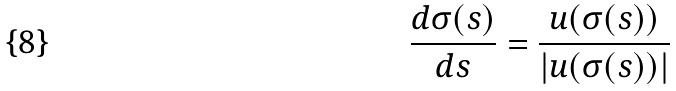Convert formula to latex. <formula><loc_0><loc_0><loc_500><loc_500>\frac { d \sigma ( s ) } { d s } = \frac { u ( \sigma ( s ) ) } { | u ( \sigma ( s ) ) | }</formula> 